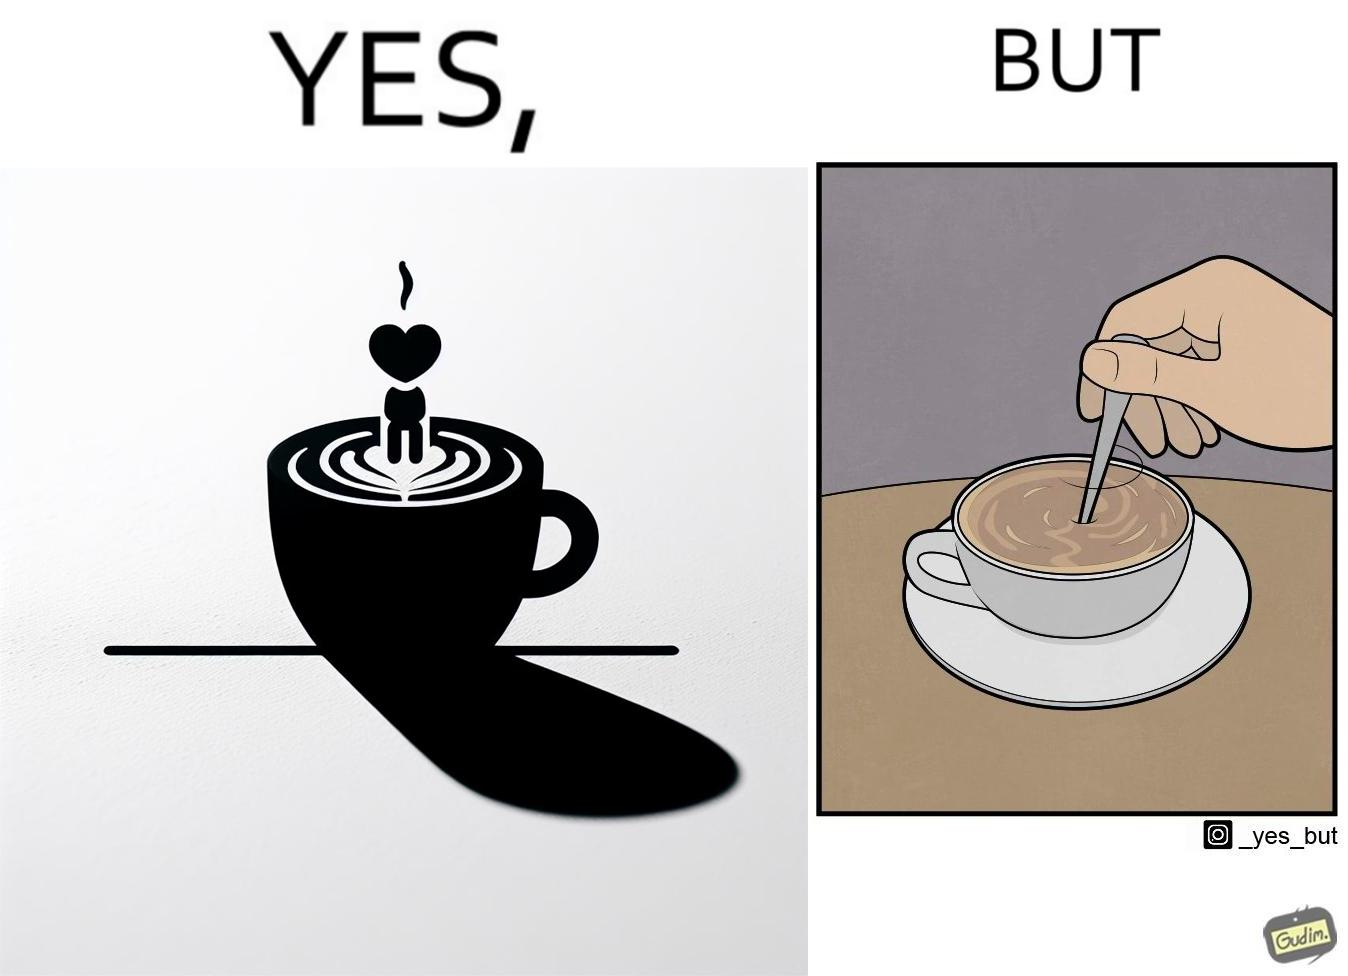Is this image satirical or non-satirical? Yes, this image is satirical. 